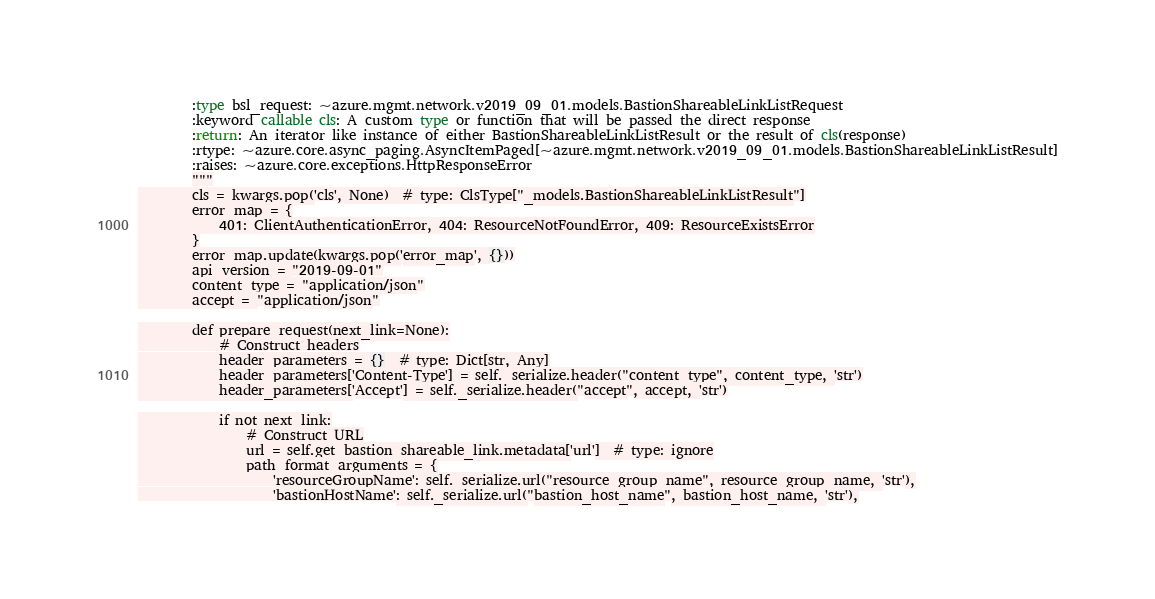<code> <loc_0><loc_0><loc_500><loc_500><_Python_>        :type bsl_request: ~azure.mgmt.network.v2019_09_01.models.BastionShareableLinkListRequest
        :keyword callable cls: A custom type or function that will be passed the direct response
        :return: An iterator like instance of either BastionShareableLinkListResult or the result of cls(response)
        :rtype: ~azure.core.async_paging.AsyncItemPaged[~azure.mgmt.network.v2019_09_01.models.BastionShareableLinkListResult]
        :raises: ~azure.core.exceptions.HttpResponseError
        """
        cls = kwargs.pop('cls', None)  # type: ClsType["_models.BastionShareableLinkListResult"]
        error_map = {
            401: ClientAuthenticationError, 404: ResourceNotFoundError, 409: ResourceExistsError
        }
        error_map.update(kwargs.pop('error_map', {}))
        api_version = "2019-09-01"
        content_type = "application/json"
        accept = "application/json"

        def prepare_request(next_link=None):
            # Construct headers
            header_parameters = {}  # type: Dict[str, Any]
            header_parameters['Content-Type'] = self._serialize.header("content_type", content_type, 'str')
            header_parameters['Accept'] = self._serialize.header("accept", accept, 'str')

            if not next_link:
                # Construct URL
                url = self.get_bastion_shareable_link.metadata['url']  # type: ignore
                path_format_arguments = {
                    'resourceGroupName': self._serialize.url("resource_group_name", resource_group_name, 'str'),
                    'bastionHostName': self._serialize.url("bastion_host_name", bastion_host_name, 'str'),</code> 